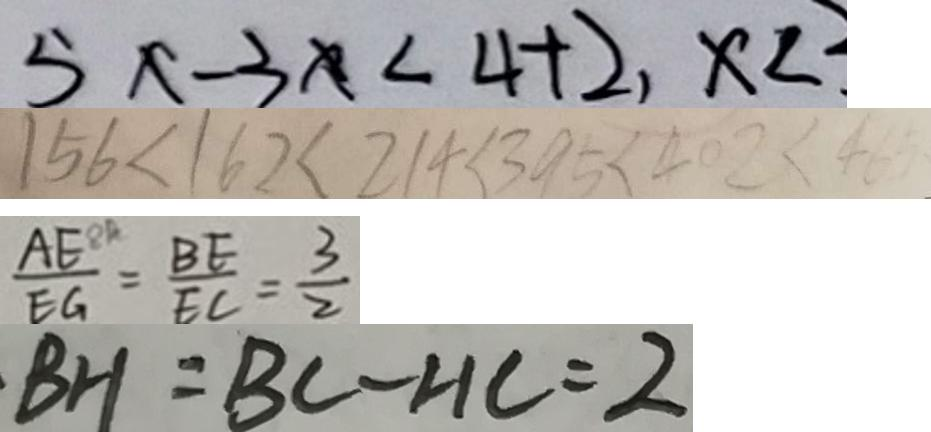Convert formula to latex. <formula><loc_0><loc_0><loc_500><loc_500>5 x - 3 x < 4 + 2 , x < 
 1 5 6 < 1 6 2 < 2 1 4 < 3 9 5 < 4 0 2 < 4 6 5 
 \frac { A E ^ { 8 R } } { E G } = \frac { B E } { E C } = \frac { 3 } { 2 } 
 \cdot B H = B C - H C = 2</formula> 